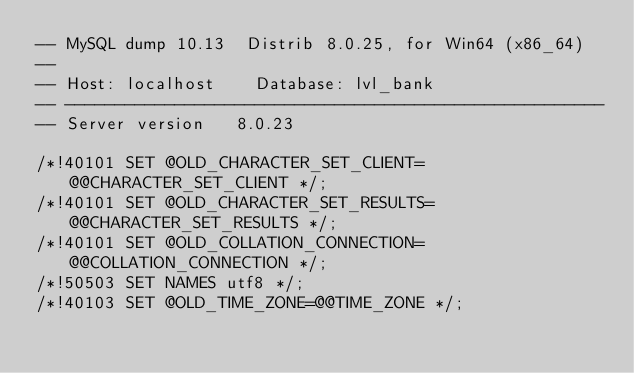Convert code to text. <code><loc_0><loc_0><loc_500><loc_500><_SQL_>-- MySQL dump 10.13  Distrib 8.0.25, for Win64 (x86_64)
--
-- Host: localhost    Database: lvl_bank
-- ------------------------------------------------------
-- Server version	8.0.23

/*!40101 SET @OLD_CHARACTER_SET_CLIENT=@@CHARACTER_SET_CLIENT */;
/*!40101 SET @OLD_CHARACTER_SET_RESULTS=@@CHARACTER_SET_RESULTS */;
/*!40101 SET @OLD_COLLATION_CONNECTION=@@COLLATION_CONNECTION */;
/*!50503 SET NAMES utf8 */;
/*!40103 SET @OLD_TIME_ZONE=@@TIME_ZONE */;</code> 